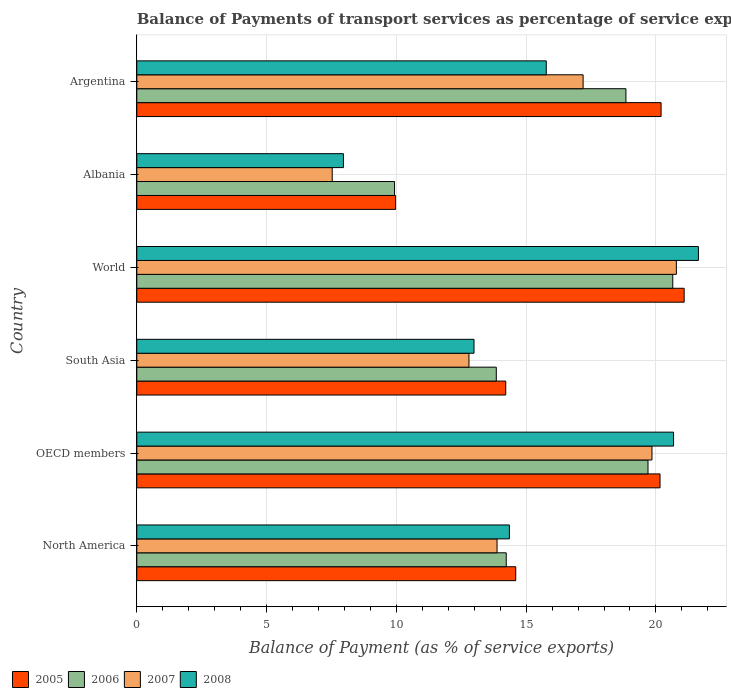How many different coloured bars are there?
Make the answer very short. 4. How many groups of bars are there?
Your response must be concise. 6. How many bars are there on the 1st tick from the top?
Your answer should be very brief. 4. How many bars are there on the 1st tick from the bottom?
Make the answer very short. 4. What is the label of the 1st group of bars from the top?
Keep it short and to the point. Argentina. In how many cases, is the number of bars for a given country not equal to the number of legend labels?
Your answer should be very brief. 0. What is the balance of payments of transport services in 2005 in South Asia?
Make the answer very short. 14.21. Across all countries, what is the maximum balance of payments of transport services in 2008?
Keep it short and to the point. 21.64. Across all countries, what is the minimum balance of payments of transport services in 2005?
Your response must be concise. 9.97. In which country was the balance of payments of transport services in 2007 maximum?
Give a very brief answer. World. In which country was the balance of payments of transport services in 2005 minimum?
Give a very brief answer. Albania. What is the total balance of payments of transport services in 2007 in the graph?
Your answer should be compact. 92.03. What is the difference between the balance of payments of transport services in 2006 in North America and that in OECD members?
Offer a terse response. -5.46. What is the difference between the balance of payments of transport services in 2008 in South Asia and the balance of payments of transport services in 2005 in OECD members?
Your response must be concise. -7.17. What is the average balance of payments of transport services in 2008 per country?
Make the answer very short. 15.57. What is the difference between the balance of payments of transport services in 2006 and balance of payments of transport services in 2005 in North America?
Offer a terse response. -0.37. In how many countries, is the balance of payments of transport services in 2008 greater than 3 %?
Provide a short and direct response. 6. What is the ratio of the balance of payments of transport services in 2008 in Argentina to that in North America?
Ensure brevity in your answer.  1.1. Is the difference between the balance of payments of transport services in 2006 in Albania and Argentina greater than the difference between the balance of payments of transport services in 2005 in Albania and Argentina?
Make the answer very short. Yes. What is the difference between the highest and the second highest balance of payments of transport services in 2007?
Make the answer very short. 0.94. What is the difference between the highest and the lowest balance of payments of transport services in 2008?
Offer a terse response. 13.68. In how many countries, is the balance of payments of transport services in 2007 greater than the average balance of payments of transport services in 2007 taken over all countries?
Keep it short and to the point. 3. Is it the case that in every country, the sum of the balance of payments of transport services in 2008 and balance of payments of transport services in 2005 is greater than the balance of payments of transport services in 2006?
Keep it short and to the point. Yes. Are all the bars in the graph horizontal?
Keep it short and to the point. Yes. How many countries are there in the graph?
Keep it short and to the point. 6. Does the graph contain any zero values?
Make the answer very short. No. Does the graph contain grids?
Your answer should be very brief. Yes. How are the legend labels stacked?
Your answer should be compact. Horizontal. What is the title of the graph?
Offer a very short reply. Balance of Payments of transport services as percentage of service exports. What is the label or title of the X-axis?
Offer a terse response. Balance of Payment (as % of service exports). What is the Balance of Payment (as % of service exports) of 2005 in North America?
Your response must be concise. 14.6. What is the Balance of Payment (as % of service exports) of 2006 in North America?
Your response must be concise. 14.23. What is the Balance of Payment (as % of service exports) in 2007 in North America?
Provide a succinct answer. 13.88. What is the Balance of Payment (as % of service exports) in 2008 in North America?
Your answer should be very brief. 14.35. What is the Balance of Payment (as % of service exports) in 2005 in OECD members?
Offer a terse response. 20.16. What is the Balance of Payment (as % of service exports) in 2006 in OECD members?
Offer a terse response. 19.69. What is the Balance of Payment (as % of service exports) in 2007 in OECD members?
Your response must be concise. 19.85. What is the Balance of Payment (as % of service exports) of 2008 in OECD members?
Your answer should be very brief. 20.68. What is the Balance of Payment (as % of service exports) of 2005 in South Asia?
Offer a very short reply. 14.21. What is the Balance of Payment (as % of service exports) of 2006 in South Asia?
Your response must be concise. 13.85. What is the Balance of Payment (as % of service exports) in 2007 in South Asia?
Give a very brief answer. 12.8. What is the Balance of Payment (as % of service exports) in 2008 in South Asia?
Offer a very short reply. 12.99. What is the Balance of Payment (as % of service exports) of 2005 in World?
Provide a short and direct response. 21.09. What is the Balance of Payment (as % of service exports) of 2006 in World?
Your response must be concise. 20.65. What is the Balance of Payment (as % of service exports) of 2007 in World?
Give a very brief answer. 20.79. What is the Balance of Payment (as % of service exports) in 2008 in World?
Keep it short and to the point. 21.64. What is the Balance of Payment (as % of service exports) of 2005 in Albania?
Offer a terse response. 9.97. What is the Balance of Payment (as % of service exports) of 2006 in Albania?
Provide a short and direct response. 9.93. What is the Balance of Payment (as % of service exports) in 2007 in Albania?
Offer a very short reply. 7.53. What is the Balance of Payment (as % of service exports) of 2008 in Albania?
Your answer should be compact. 7.96. What is the Balance of Payment (as % of service exports) in 2005 in Argentina?
Your answer should be compact. 20.2. What is the Balance of Payment (as % of service exports) in 2006 in Argentina?
Offer a terse response. 18.84. What is the Balance of Payment (as % of service exports) of 2007 in Argentina?
Your response must be concise. 17.19. What is the Balance of Payment (as % of service exports) in 2008 in Argentina?
Your response must be concise. 15.78. Across all countries, what is the maximum Balance of Payment (as % of service exports) of 2005?
Your answer should be compact. 21.09. Across all countries, what is the maximum Balance of Payment (as % of service exports) of 2006?
Your answer should be compact. 20.65. Across all countries, what is the maximum Balance of Payment (as % of service exports) of 2007?
Provide a short and direct response. 20.79. Across all countries, what is the maximum Balance of Payment (as % of service exports) of 2008?
Your answer should be compact. 21.64. Across all countries, what is the minimum Balance of Payment (as % of service exports) of 2005?
Your answer should be very brief. 9.97. Across all countries, what is the minimum Balance of Payment (as % of service exports) in 2006?
Ensure brevity in your answer.  9.93. Across all countries, what is the minimum Balance of Payment (as % of service exports) of 2007?
Offer a very short reply. 7.53. Across all countries, what is the minimum Balance of Payment (as % of service exports) of 2008?
Provide a short and direct response. 7.96. What is the total Balance of Payment (as % of service exports) of 2005 in the graph?
Make the answer very short. 100.23. What is the total Balance of Payment (as % of service exports) in 2006 in the graph?
Your answer should be compact. 97.2. What is the total Balance of Payment (as % of service exports) in 2007 in the graph?
Provide a succinct answer. 92.03. What is the total Balance of Payment (as % of service exports) in 2008 in the graph?
Offer a very short reply. 93.4. What is the difference between the Balance of Payment (as % of service exports) in 2005 in North America and that in OECD members?
Give a very brief answer. -5.56. What is the difference between the Balance of Payment (as % of service exports) of 2006 in North America and that in OECD members?
Ensure brevity in your answer.  -5.46. What is the difference between the Balance of Payment (as % of service exports) in 2007 in North America and that in OECD members?
Your response must be concise. -5.97. What is the difference between the Balance of Payment (as % of service exports) of 2008 in North America and that in OECD members?
Ensure brevity in your answer.  -6.32. What is the difference between the Balance of Payment (as % of service exports) of 2005 in North America and that in South Asia?
Offer a terse response. 0.38. What is the difference between the Balance of Payment (as % of service exports) of 2006 in North America and that in South Asia?
Give a very brief answer. 0.38. What is the difference between the Balance of Payment (as % of service exports) of 2007 in North America and that in South Asia?
Give a very brief answer. 1.08. What is the difference between the Balance of Payment (as % of service exports) in 2008 in North America and that in South Asia?
Provide a succinct answer. 1.36. What is the difference between the Balance of Payment (as % of service exports) in 2005 in North America and that in World?
Ensure brevity in your answer.  -6.49. What is the difference between the Balance of Payment (as % of service exports) of 2006 in North America and that in World?
Offer a terse response. -6.42. What is the difference between the Balance of Payment (as % of service exports) of 2007 in North America and that in World?
Offer a terse response. -6.91. What is the difference between the Balance of Payment (as % of service exports) of 2008 in North America and that in World?
Your answer should be compact. -7.28. What is the difference between the Balance of Payment (as % of service exports) of 2005 in North America and that in Albania?
Offer a very short reply. 4.63. What is the difference between the Balance of Payment (as % of service exports) of 2006 in North America and that in Albania?
Keep it short and to the point. 4.3. What is the difference between the Balance of Payment (as % of service exports) in 2007 in North America and that in Albania?
Ensure brevity in your answer.  6.35. What is the difference between the Balance of Payment (as % of service exports) in 2008 in North America and that in Albania?
Keep it short and to the point. 6.39. What is the difference between the Balance of Payment (as % of service exports) of 2005 in North America and that in Argentina?
Provide a succinct answer. -5.6. What is the difference between the Balance of Payment (as % of service exports) in 2006 in North America and that in Argentina?
Your answer should be compact. -4.61. What is the difference between the Balance of Payment (as % of service exports) in 2007 in North America and that in Argentina?
Offer a very short reply. -3.32. What is the difference between the Balance of Payment (as % of service exports) in 2008 in North America and that in Argentina?
Make the answer very short. -1.42. What is the difference between the Balance of Payment (as % of service exports) in 2005 in OECD members and that in South Asia?
Provide a short and direct response. 5.94. What is the difference between the Balance of Payment (as % of service exports) in 2006 in OECD members and that in South Asia?
Your answer should be very brief. 5.84. What is the difference between the Balance of Payment (as % of service exports) in 2007 in OECD members and that in South Asia?
Give a very brief answer. 7.05. What is the difference between the Balance of Payment (as % of service exports) of 2008 in OECD members and that in South Asia?
Give a very brief answer. 7.69. What is the difference between the Balance of Payment (as % of service exports) of 2005 in OECD members and that in World?
Ensure brevity in your answer.  -0.93. What is the difference between the Balance of Payment (as % of service exports) in 2006 in OECD members and that in World?
Your answer should be very brief. -0.95. What is the difference between the Balance of Payment (as % of service exports) in 2007 in OECD members and that in World?
Provide a short and direct response. -0.94. What is the difference between the Balance of Payment (as % of service exports) of 2008 in OECD members and that in World?
Keep it short and to the point. -0.96. What is the difference between the Balance of Payment (as % of service exports) in 2005 in OECD members and that in Albania?
Keep it short and to the point. 10.19. What is the difference between the Balance of Payment (as % of service exports) in 2006 in OECD members and that in Albania?
Give a very brief answer. 9.76. What is the difference between the Balance of Payment (as % of service exports) of 2007 in OECD members and that in Albania?
Offer a terse response. 12.32. What is the difference between the Balance of Payment (as % of service exports) of 2008 in OECD members and that in Albania?
Your response must be concise. 12.72. What is the difference between the Balance of Payment (as % of service exports) in 2005 in OECD members and that in Argentina?
Provide a succinct answer. -0.04. What is the difference between the Balance of Payment (as % of service exports) of 2006 in OECD members and that in Argentina?
Make the answer very short. 0.85. What is the difference between the Balance of Payment (as % of service exports) in 2007 in OECD members and that in Argentina?
Make the answer very short. 2.65. What is the difference between the Balance of Payment (as % of service exports) of 2008 in OECD members and that in Argentina?
Provide a short and direct response. 4.9. What is the difference between the Balance of Payment (as % of service exports) in 2005 in South Asia and that in World?
Provide a short and direct response. -6.87. What is the difference between the Balance of Payment (as % of service exports) in 2006 in South Asia and that in World?
Offer a very short reply. -6.8. What is the difference between the Balance of Payment (as % of service exports) in 2007 in South Asia and that in World?
Your answer should be compact. -7.99. What is the difference between the Balance of Payment (as % of service exports) in 2008 in South Asia and that in World?
Offer a very short reply. -8.64. What is the difference between the Balance of Payment (as % of service exports) of 2005 in South Asia and that in Albania?
Your response must be concise. 4.24. What is the difference between the Balance of Payment (as % of service exports) of 2006 in South Asia and that in Albania?
Your answer should be compact. 3.92. What is the difference between the Balance of Payment (as % of service exports) of 2007 in South Asia and that in Albania?
Your response must be concise. 5.27. What is the difference between the Balance of Payment (as % of service exports) of 2008 in South Asia and that in Albania?
Ensure brevity in your answer.  5.03. What is the difference between the Balance of Payment (as % of service exports) of 2005 in South Asia and that in Argentina?
Provide a succinct answer. -5.98. What is the difference between the Balance of Payment (as % of service exports) of 2006 in South Asia and that in Argentina?
Give a very brief answer. -4.99. What is the difference between the Balance of Payment (as % of service exports) of 2007 in South Asia and that in Argentina?
Provide a short and direct response. -4.4. What is the difference between the Balance of Payment (as % of service exports) of 2008 in South Asia and that in Argentina?
Provide a succinct answer. -2.78. What is the difference between the Balance of Payment (as % of service exports) in 2005 in World and that in Albania?
Provide a succinct answer. 11.12. What is the difference between the Balance of Payment (as % of service exports) in 2006 in World and that in Albania?
Keep it short and to the point. 10.72. What is the difference between the Balance of Payment (as % of service exports) of 2007 in World and that in Albania?
Offer a very short reply. 13.26. What is the difference between the Balance of Payment (as % of service exports) of 2008 in World and that in Albania?
Provide a short and direct response. 13.68. What is the difference between the Balance of Payment (as % of service exports) of 2005 in World and that in Argentina?
Your response must be concise. 0.89. What is the difference between the Balance of Payment (as % of service exports) of 2006 in World and that in Argentina?
Your answer should be compact. 1.8. What is the difference between the Balance of Payment (as % of service exports) of 2007 in World and that in Argentina?
Your answer should be compact. 3.59. What is the difference between the Balance of Payment (as % of service exports) in 2008 in World and that in Argentina?
Your answer should be compact. 5.86. What is the difference between the Balance of Payment (as % of service exports) of 2005 in Albania and that in Argentina?
Offer a terse response. -10.23. What is the difference between the Balance of Payment (as % of service exports) in 2006 in Albania and that in Argentina?
Your answer should be compact. -8.91. What is the difference between the Balance of Payment (as % of service exports) of 2007 in Albania and that in Argentina?
Make the answer very short. -9.67. What is the difference between the Balance of Payment (as % of service exports) in 2008 in Albania and that in Argentina?
Offer a very short reply. -7.81. What is the difference between the Balance of Payment (as % of service exports) in 2005 in North America and the Balance of Payment (as % of service exports) in 2006 in OECD members?
Ensure brevity in your answer.  -5.1. What is the difference between the Balance of Payment (as % of service exports) of 2005 in North America and the Balance of Payment (as % of service exports) of 2007 in OECD members?
Offer a terse response. -5.25. What is the difference between the Balance of Payment (as % of service exports) in 2005 in North America and the Balance of Payment (as % of service exports) in 2008 in OECD members?
Keep it short and to the point. -6.08. What is the difference between the Balance of Payment (as % of service exports) of 2006 in North America and the Balance of Payment (as % of service exports) of 2007 in OECD members?
Give a very brief answer. -5.61. What is the difference between the Balance of Payment (as % of service exports) in 2006 in North America and the Balance of Payment (as % of service exports) in 2008 in OECD members?
Give a very brief answer. -6.45. What is the difference between the Balance of Payment (as % of service exports) of 2007 in North America and the Balance of Payment (as % of service exports) of 2008 in OECD members?
Make the answer very short. -6.8. What is the difference between the Balance of Payment (as % of service exports) in 2005 in North America and the Balance of Payment (as % of service exports) in 2006 in South Asia?
Give a very brief answer. 0.75. What is the difference between the Balance of Payment (as % of service exports) in 2005 in North America and the Balance of Payment (as % of service exports) in 2007 in South Asia?
Keep it short and to the point. 1.8. What is the difference between the Balance of Payment (as % of service exports) in 2005 in North America and the Balance of Payment (as % of service exports) in 2008 in South Asia?
Your response must be concise. 1.61. What is the difference between the Balance of Payment (as % of service exports) in 2006 in North America and the Balance of Payment (as % of service exports) in 2007 in South Asia?
Offer a terse response. 1.44. What is the difference between the Balance of Payment (as % of service exports) of 2006 in North America and the Balance of Payment (as % of service exports) of 2008 in South Asia?
Provide a short and direct response. 1.24. What is the difference between the Balance of Payment (as % of service exports) of 2007 in North America and the Balance of Payment (as % of service exports) of 2008 in South Asia?
Ensure brevity in your answer.  0.89. What is the difference between the Balance of Payment (as % of service exports) in 2005 in North America and the Balance of Payment (as % of service exports) in 2006 in World?
Give a very brief answer. -6.05. What is the difference between the Balance of Payment (as % of service exports) of 2005 in North America and the Balance of Payment (as % of service exports) of 2007 in World?
Your answer should be very brief. -6.19. What is the difference between the Balance of Payment (as % of service exports) in 2005 in North America and the Balance of Payment (as % of service exports) in 2008 in World?
Make the answer very short. -7.04. What is the difference between the Balance of Payment (as % of service exports) of 2006 in North America and the Balance of Payment (as % of service exports) of 2007 in World?
Offer a terse response. -6.55. What is the difference between the Balance of Payment (as % of service exports) in 2006 in North America and the Balance of Payment (as % of service exports) in 2008 in World?
Provide a short and direct response. -7.4. What is the difference between the Balance of Payment (as % of service exports) of 2007 in North America and the Balance of Payment (as % of service exports) of 2008 in World?
Offer a very short reply. -7.76. What is the difference between the Balance of Payment (as % of service exports) of 2005 in North America and the Balance of Payment (as % of service exports) of 2006 in Albania?
Make the answer very short. 4.67. What is the difference between the Balance of Payment (as % of service exports) of 2005 in North America and the Balance of Payment (as % of service exports) of 2007 in Albania?
Provide a short and direct response. 7.07. What is the difference between the Balance of Payment (as % of service exports) of 2005 in North America and the Balance of Payment (as % of service exports) of 2008 in Albania?
Keep it short and to the point. 6.64. What is the difference between the Balance of Payment (as % of service exports) in 2006 in North America and the Balance of Payment (as % of service exports) in 2007 in Albania?
Ensure brevity in your answer.  6.7. What is the difference between the Balance of Payment (as % of service exports) of 2006 in North America and the Balance of Payment (as % of service exports) of 2008 in Albania?
Your answer should be very brief. 6.27. What is the difference between the Balance of Payment (as % of service exports) of 2007 in North America and the Balance of Payment (as % of service exports) of 2008 in Albania?
Your answer should be very brief. 5.92. What is the difference between the Balance of Payment (as % of service exports) of 2005 in North America and the Balance of Payment (as % of service exports) of 2006 in Argentina?
Offer a terse response. -4.24. What is the difference between the Balance of Payment (as % of service exports) in 2005 in North America and the Balance of Payment (as % of service exports) in 2007 in Argentina?
Keep it short and to the point. -2.6. What is the difference between the Balance of Payment (as % of service exports) of 2005 in North America and the Balance of Payment (as % of service exports) of 2008 in Argentina?
Offer a very short reply. -1.18. What is the difference between the Balance of Payment (as % of service exports) in 2006 in North America and the Balance of Payment (as % of service exports) in 2007 in Argentina?
Your response must be concise. -2.96. What is the difference between the Balance of Payment (as % of service exports) in 2006 in North America and the Balance of Payment (as % of service exports) in 2008 in Argentina?
Your answer should be very brief. -1.54. What is the difference between the Balance of Payment (as % of service exports) of 2007 in North America and the Balance of Payment (as % of service exports) of 2008 in Argentina?
Make the answer very short. -1.9. What is the difference between the Balance of Payment (as % of service exports) of 2005 in OECD members and the Balance of Payment (as % of service exports) of 2006 in South Asia?
Your response must be concise. 6.31. What is the difference between the Balance of Payment (as % of service exports) in 2005 in OECD members and the Balance of Payment (as % of service exports) in 2007 in South Asia?
Provide a succinct answer. 7.36. What is the difference between the Balance of Payment (as % of service exports) in 2005 in OECD members and the Balance of Payment (as % of service exports) in 2008 in South Asia?
Provide a succinct answer. 7.17. What is the difference between the Balance of Payment (as % of service exports) of 2006 in OECD members and the Balance of Payment (as % of service exports) of 2007 in South Asia?
Give a very brief answer. 6.9. What is the difference between the Balance of Payment (as % of service exports) of 2006 in OECD members and the Balance of Payment (as % of service exports) of 2008 in South Asia?
Give a very brief answer. 6.7. What is the difference between the Balance of Payment (as % of service exports) of 2007 in OECD members and the Balance of Payment (as % of service exports) of 2008 in South Asia?
Offer a terse response. 6.86. What is the difference between the Balance of Payment (as % of service exports) in 2005 in OECD members and the Balance of Payment (as % of service exports) in 2006 in World?
Ensure brevity in your answer.  -0.49. What is the difference between the Balance of Payment (as % of service exports) in 2005 in OECD members and the Balance of Payment (as % of service exports) in 2007 in World?
Provide a succinct answer. -0.63. What is the difference between the Balance of Payment (as % of service exports) of 2005 in OECD members and the Balance of Payment (as % of service exports) of 2008 in World?
Give a very brief answer. -1.48. What is the difference between the Balance of Payment (as % of service exports) of 2006 in OECD members and the Balance of Payment (as % of service exports) of 2007 in World?
Offer a very short reply. -1.09. What is the difference between the Balance of Payment (as % of service exports) of 2006 in OECD members and the Balance of Payment (as % of service exports) of 2008 in World?
Keep it short and to the point. -1.94. What is the difference between the Balance of Payment (as % of service exports) of 2007 in OECD members and the Balance of Payment (as % of service exports) of 2008 in World?
Give a very brief answer. -1.79. What is the difference between the Balance of Payment (as % of service exports) in 2005 in OECD members and the Balance of Payment (as % of service exports) in 2006 in Albania?
Ensure brevity in your answer.  10.23. What is the difference between the Balance of Payment (as % of service exports) of 2005 in OECD members and the Balance of Payment (as % of service exports) of 2007 in Albania?
Your answer should be compact. 12.63. What is the difference between the Balance of Payment (as % of service exports) in 2005 in OECD members and the Balance of Payment (as % of service exports) in 2008 in Albania?
Your answer should be very brief. 12.2. What is the difference between the Balance of Payment (as % of service exports) of 2006 in OECD members and the Balance of Payment (as % of service exports) of 2007 in Albania?
Keep it short and to the point. 12.17. What is the difference between the Balance of Payment (as % of service exports) in 2006 in OECD members and the Balance of Payment (as % of service exports) in 2008 in Albania?
Offer a very short reply. 11.73. What is the difference between the Balance of Payment (as % of service exports) of 2007 in OECD members and the Balance of Payment (as % of service exports) of 2008 in Albania?
Offer a terse response. 11.89. What is the difference between the Balance of Payment (as % of service exports) in 2005 in OECD members and the Balance of Payment (as % of service exports) in 2006 in Argentina?
Provide a succinct answer. 1.31. What is the difference between the Balance of Payment (as % of service exports) of 2005 in OECD members and the Balance of Payment (as % of service exports) of 2007 in Argentina?
Keep it short and to the point. 2.96. What is the difference between the Balance of Payment (as % of service exports) of 2005 in OECD members and the Balance of Payment (as % of service exports) of 2008 in Argentina?
Ensure brevity in your answer.  4.38. What is the difference between the Balance of Payment (as % of service exports) in 2006 in OECD members and the Balance of Payment (as % of service exports) in 2007 in Argentina?
Keep it short and to the point. 2.5. What is the difference between the Balance of Payment (as % of service exports) in 2006 in OECD members and the Balance of Payment (as % of service exports) in 2008 in Argentina?
Your response must be concise. 3.92. What is the difference between the Balance of Payment (as % of service exports) of 2007 in OECD members and the Balance of Payment (as % of service exports) of 2008 in Argentina?
Provide a succinct answer. 4.07. What is the difference between the Balance of Payment (as % of service exports) in 2005 in South Asia and the Balance of Payment (as % of service exports) in 2006 in World?
Your answer should be compact. -6.43. What is the difference between the Balance of Payment (as % of service exports) in 2005 in South Asia and the Balance of Payment (as % of service exports) in 2007 in World?
Make the answer very short. -6.57. What is the difference between the Balance of Payment (as % of service exports) in 2005 in South Asia and the Balance of Payment (as % of service exports) in 2008 in World?
Keep it short and to the point. -7.42. What is the difference between the Balance of Payment (as % of service exports) of 2006 in South Asia and the Balance of Payment (as % of service exports) of 2007 in World?
Make the answer very short. -6.94. What is the difference between the Balance of Payment (as % of service exports) of 2006 in South Asia and the Balance of Payment (as % of service exports) of 2008 in World?
Your response must be concise. -7.79. What is the difference between the Balance of Payment (as % of service exports) of 2007 in South Asia and the Balance of Payment (as % of service exports) of 2008 in World?
Ensure brevity in your answer.  -8.84. What is the difference between the Balance of Payment (as % of service exports) of 2005 in South Asia and the Balance of Payment (as % of service exports) of 2006 in Albania?
Your response must be concise. 4.28. What is the difference between the Balance of Payment (as % of service exports) in 2005 in South Asia and the Balance of Payment (as % of service exports) in 2007 in Albania?
Make the answer very short. 6.68. What is the difference between the Balance of Payment (as % of service exports) of 2005 in South Asia and the Balance of Payment (as % of service exports) of 2008 in Albania?
Make the answer very short. 6.25. What is the difference between the Balance of Payment (as % of service exports) in 2006 in South Asia and the Balance of Payment (as % of service exports) in 2007 in Albania?
Your answer should be compact. 6.32. What is the difference between the Balance of Payment (as % of service exports) in 2006 in South Asia and the Balance of Payment (as % of service exports) in 2008 in Albania?
Your answer should be very brief. 5.89. What is the difference between the Balance of Payment (as % of service exports) in 2007 in South Asia and the Balance of Payment (as % of service exports) in 2008 in Albania?
Keep it short and to the point. 4.84. What is the difference between the Balance of Payment (as % of service exports) of 2005 in South Asia and the Balance of Payment (as % of service exports) of 2006 in Argentina?
Offer a terse response. -4.63. What is the difference between the Balance of Payment (as % of service exports) of 2005 in South Asia and the Balance of Payment (as % of service exports) of 2007 in Argentina?
Offer a terse response. -2.98. What is the difference between the Balance of Payment (as % of service exports) of 2005 in South Asia and the Balance of Payment (as % of service exports) of 2008 in Argentina?
Provide a succinct answer. -1.56. What is the difference between the Balance of Payment (as % of service exports) of 2006 in South Asia and the Balance of Payment (as % of service exports) of 2007 in Argentina?
Ensure brevity in your answer.  -3.34. What is the difference between the Balance of Payment (as % of service exports) in 2006 in South Asia and the Balance of Payment (as % of service exports) in 2008 in Argentina?
Give a very brief answer. -1.93. What is the difference between the Balance of Payment (as % of service exports) of 2007 in South Asia and the Balance of Payment (as % of service exports) of 2008 in Argentina?
Your response must be concise. -2.98. What is the difference between the Balance of Payment (as % of service exports) of 2005 in World and the Balance of Payment (as % of service exports) of 2006 in Albania?
Provide a succinct answer. 11.16. What is the difference between the Balance of Payment (as % of service exports) of 2005 in World and the Balance of Payment (as % of service exports) of 2007 in Albania?
Give a very brief answer. 13.56. What is the difference between the Balance of Payment (as % of service exports) of 2005 in World and the Balance of Payment (as % of service exports) of 2008 in Albania?
Your answer should be compact. 13.13. What is the difference between the Balance of Payment (as % of service exports) in 2006 in World and the Balance of Payment (as % of service exports) in 2007 in Albania?
Make the answer very short. 13.12. What is the difference between the Balance of Payment (as % of service exports) of 2006 in World and the Balance of Payment (as % of service exports) of 2008 in Albania?
Your response must be concise. 12.69. What is the difference between the Balance of Payment (as % of service exports) in 2007 in World and the Balance of Payment (as % of service exports) in 2008 in Albania?
Make the answer very short. 12.83. What is the difference between the Balance of Payment (as % of service exports) of 2005 in World and the Balance of Payment (as % of service exports) of 2006 in Argentina?
Keep it short and to the point. 2.24. What is the difference between the Balance of Payment (as % of service exports) in 2005 in World and the Balance of Payment (as % of service exports) in 2007 in Argentina?
Offer a very short reply. 3.89. What is the difference between the Balance of Payment (as % of service exports) in 2005 in World and the Balance of Payment (as % of service exports) in 2008 in Argentina?
Your response must be concise. 5.31. What is the difference between the Balance of Payment (as % of service exports) of 2006 in World and the Balance of Payment (as % of service exports) of 2007 in Argentina?
Offer a very short reply. 3.45. What is the difference between the Balance of Payment (as % of service exports) of 2006 in World and the Balance of Payment (as % of service exports) of 2008 in Argentina?
Ensure brevity in your answer.  4.87. What is the difference between the Balance of Payment (as % of service exports) of 2007 in World and the Balance of Payment (as % of service exports) of 2008 in Argentina?
Give a very brief answer. 5.01. What is the difference between the Balance of Payment (as % of service exports) in 2005 in Albania and the Balance of Payment (as % of service exports) in 2006 in Argentina?
Keep it short and to the point. -8.87. What is the difference between the Balance of Payment (as % of service exports) in 2005 in Albania and the Balance of Payment (as % of service exports) in 2007 in Argentina?
Your answer should be very brief. -7.22. What is the difference between the Balance of Payment (as % of service exports) in 2005 in Albania and the Balance of Payment (as % of service exports) in 2008 in Argentina?
Your response must be concise. -5.8. What is the difference between the Balance of Payment (as % of service exports) in 2006 in Albania and the Balance of Payment (as % of service exports) in 2007 in Argentina?
Keep it short and to the point. -7.26. What is the difference between the Balance of Payment (as % of service exports) of 2006 in Albania and the Balance of Payment (as % of service exports) of 2008 in Argentina?
Offer a very short reply. -5.85. What is the difference between the Balance of Payment (as % of service exports) in 2007 in Albania and the Balance of Payment (as % of service exports) in 2008 in Argentina?
Provide a succinct answer. -8.25. What is the average Balance of Payment (as % of service exports) in 2005 per country?
Offer a very short reply. 16.7. What is the average Balance of Payment (as % of service exports) in 2006 per country?
Offer a very short reply. 16.2. What is the average Balance of Payment (as % of service exports) in 2007 per country?
Provide a succinct answer. 15.34. What is the average Balance of Payment (as % of service exports) in 2008 per country?
Provide a succinct answer. 15.57. What is the difference between the Balance of Payment (as % of service exports) in 2005 and Balance of Payment (as % of service exports) in 2006 in North America?
Make the answer very short. 0.37. What is the difference between the Balance of Payment (as % of service exports) in 2005 and Balance of Payment (as % of service exports) in 2007 in North America?
Provide a succinct answer. 0.72. What is the difference between the Balance of Payment (as % of service exports) in 2005 and Balance of Payment (as % of service exports) in 2008 in North America?
Offer a terse response. 0.24. What is the difference between the Balance of Payment (as % of service exports) of 2006 and Balance of Payment (as % of service exports) of 2007 in North America?
Offer a terse response. 0.35. What is the difference between the Balance of Payment (as % of service exports) of 2006 and Balance of Payment (as % of service exports) of 2008 in North America?
Keep it short and to the point. -0.12. What is the difference between the Balance of Payment (as % of service exports) in 2007 and Balance of Payment (as % of service exports) in 2008 in North America?
Make the answer very short. -0.48. What is the difference between the Balance of Payment (as % of service exports) of 2005 and Balance of Payment (as % of service exports) of 2006 in OECD members?
Your response must be concise. 0.46. What is the difference between the Balance of Payment (as % of service exports) in 2005 and Balance of Payment (as % of service exports) in 2007 in OECD members?
Your answer should be compact. 0.31. What is the difference between the Balance of Payment (as % of service exports) in 2005 and Balance of Payment (as % of service exports) in 2008 in OECD members?
Make the answer very short. -0.52. What is the difference between the Balance of Payment (as % of service exports) of 2006 and Balance of Payment (as % of service exports) of 2007 in OECD members?
Make the answer very short. -0.15. What is the difference between the Balance of Payment (as % of service exports) of 2006 and Balance of Payment (as % of service exports) of 2008 in OECD members?
Provide a succinct answer. -0.98. What is the difference between the Balance of Payment (as % of service exports) in 2007 and Balance of Payment (as % of service exports) in 2008 in OECD members?
Your answer should be compact. -0.83. What is the difference between the Balance of Payment (as % of service exports) in 2005 and Balance of Payment (as % of service exports) in 2006 in South Asia?
Your answer should be compact. 0.36. What is the difference between the Balance of Payment (as % of service exports) in 2005 and Balance of Payment (as % of service exports) in 2007 in South Asia?
Ensure brevity in your answer.  1.42. What is the difference between the Balance of Payment (as % of service exports) in 2005 and Balance of Payment (as % of service exports) in 2008 in South Asia?
Offer a terse response. 1.22. What is the difference between the Balance of Payment (as % of service exports) in 2006 and Balance of Payment (as % of service exports) in 2007 in South Asia?
Provide a succinct answer. 1.05. What is the difference between the Balance of Payment (as % of service exports) of 2006 and Balance of Payment (as % of service exports) of 2008 in South Asia?
Your response must be concise. 0.86. What is the difference between the Balance of Payment (as % of service exports) of 2007 and Balance of Payment (as % of service exports) of 2008 in South Asia?
Give a very brief answer. -0.19. What is the difference between the Balance of Payment (as % of service exports) of 2005 and Balance of Payment (as % of service exports) of 2006 in World?
Provide a succinct answer. 0.44. What is the difference between the Balance of Payment (as % of service exports) of 2005 and Balance of Payment (as % of service exports) of 2007 in World?
Offer a very short reply. 0.3. What is the difference between the Balance of Payment (as % of service exports) of 2005 and Balance of Payment (as % of service exports) of 2008 in World?
Offer a very short reply. -0.55. What is the difference between the Balance of Payment (as % of service exports) of 2006 and Balance of Payment (as % of service exports) of 2007 in World?
Ensure brevity in your answer.  -0.14. What is the difference between the Balance of Payment (as % of service exports) in 2006 and Balance of Payment (as % of service exports) in 2008 in World?
Ensure brevity in your answer.  -0.99. What is the difference between the Balance of Payment (as % of service exports) in 2007 and Balance of Payment (as % of service exports) in 2008 in World?
Keep it short and to the point. -0.85. What is the difference between the Balance of Payment (as % of service exports) in 2005 and Balance of Payment (as % of service exports) in 2006 in Albania?
Ensure brevity in your answer.  0.04. What is the difference between the Balance of Payment (as % of service exports) of 2005 and Balance of Payment (as % of service exports) of 2007 in Albania?
Give a very brief answer. 2.44. What is the difference between the Balance of Payment (as % of service exports) of 2005 and Balance of Payment (as % of service exports) of 2008 in Albania?
Your response must be concise. 2.01. What is the difference between the Balance of Payment (as % of service exports) of 2006 and Balance of Payment (as % of service exports) of 2007 in Albania?
Provide a succinct answer. 2.4. What is the difference between the Balance of Payment (as % of service exports) of 2006 and Balance of Payment (as % of service exports) of 2008 in Albania?
Provide a short and direct response. 1.97. What is the difference between the Balance of Payment (as % of service exports) of 2007 and Balance of Payment (as % of service exports) of 2008 in Albania?
Provide a short and direct response. -0.43. What is the difference between the Balance of Payment (as % of service exports) of 2005 and Balance of Payment (as % of service exports) of 2006 in Argentina?
Your response must be concise. 1.35. What is the difference between the Balance of Payment (as % of service exports) in 2005 and Balance of Payment (as % of service exports) in 2007 in Argentina?
Your answer should be very brief. 3. What is the difference between the Balance of Payment (as % of service exports) of 2005 and Balance of Payment (as % of service exports) of 2008 in Argentina?
Provide a succinct answer. 4.42. What is the difference between the Balance of Payment (as % of service exports) of 2006 and Balance of Payment (as % of service exports) of 2007 in Argentina?
Ensure brevity in your answer.  1.65. What is the difference between the Balance of Payment (as % of service exports) in 2006 and Balance of Payment (as % of service exports) in 2008 in Argentina?
Your answer should be compact. 3.07. What is the difference between the Balance of Payment (as % of service exports) in 2007 and Balance of Payment (as % of service exports) in 2008 in Argentina?
Keep it short and to the point. 1.42. What is the ratio of the Balance of Payment (as % of service exports) in 2005 in North America to that in OECD members?
Your answer should be very brief. 0.72. What is the ratio of the Balance of Payment (as % of service exports) of 2006 in North America to that in OECD members?
Give a very brief answer. 0.72. What is the ratio of the Balance of Payment (as % of service exports) in 2007 in North America to that in OECD members?
Ensure brevity in your answer.  0.7. What is the ratio of the Balance of Payment (as % of service exports) of 2008 in North America to that in OECD members?
Give a very brief answer. 0.69. What is the ratio of the Balance of Payment (as % of service exports) of 2005 in North America to that in South Asia?
Your answer should be very brief. 1.03. What is the ratio of the Balance of Payment (as % of service exports) in 2006 in North America to that in South Asia?
Keep it short and to the point. 1.03. What is the ratio of the Balance of Payment (as % of service exports) of 2007 in North America to that in South Asia?
Ensure brevity in your answer.  1.08. What is the ratio of the Balance of Payment (as % of service exports) of 2008 in North America to that in South Asia?
Keep it short and to the point. 1.1. What is the ratio of the Balance of Payment (as % of service exports) in 2005 in North America to that in World?
Give a very brief answer. 0.69. What is the ratio of the Balance of Payment (as % of service exports) in 2006 in North America to that in World?
Offer a very short reply. 0.69. What is the ratio of the Balance of Payment (as % of service exports) in 2007 in North America to that in World?
Give a very brief answer. 0.67. What is the ratio of the Balance of Payment (as % of service exports) in 2008 in North America to that in World?
Offer a very short reply. 0.66. What is the ratio of the Balance of Payment (as % of service exports) in 2005 in North America to that in Albania?
Your response must be concise. 1.46. What is the ratio of the Balance of Payment (as % of service exports) of 2006 in North America to that in Albania?
Provide a succinct answer. 1.43. What is the ratio of the Balance of Payment (as % of service exports) in 2007 in North America to that in Albania?
Give a very brief answer. 1.84. What is the ratio of the Balance of Payment (as % of service exports) in 2008 in North America to that in Albania?
Provide a short and direct response. 1.8. What is the ratio of the Balance of Payment (as % of service exports) of 2005 in North America to that in Argentina?
Your answer should be compact. 0.72. What is the ratio of the Balance of Payment (as % of service exports) of 2006 in North America to that in Argentina?
Give a very brief answer. 0.76. What is the ratio of the Balance of Payment (as % of service exports) in 2007 in North America to that in Argentina?
Ensure brevity in your answer.  0.81. What is the ratio of the Balance of Payment (as % of service exports) of 2008 in North America to that in Argentina?
Your answer should be very brief. 0.91. What is the ratio of the Balance of Payment (as % of service exports) in 2005 in OECD members to that in South Asia?
Provide a succinct answer. 1.42. What is the ratio of the Balance of Payment (as % of service exports) in 2006 in OECD members to that in South Asia?
Your answer should be very brief. 1.42. What is the ratio of the Balance of Payment (as % of service exports) in 2007 in OECD members to that in South Asia?
Provide a short and direct response. 1.55. What is the ratio of the Balance of Payment (as % of service exports) of 2008 in OECD members to that in South Asia?
Offer a terse response. 1.59. What is the ratio of the Balance of Payment (as % of service exports) in 2005 in OECD members to that in World?
Your response must be concise. 0.96. What is the ratio of the Balance of Payment (as % of service exports) in 2006 in OECD members to that in World?
Offer a very short reply. 0.95. What is the ratio of the Balance of Payment (as % of service exports) in 2007 in OECD members to that in World?
Ensure brevity in your answer.  0.95. What is the ratio of the Balance of Payment (as % of service exports) in 2008 in OECD members to that in World?
Offer a terse response. 0.96. What is the ratio of the Balance of Payment (as % of service exports) in 2005 in OECD members to that in Albania?
Give a very brief answer. 2.02. What is the ratio of the Balance of Payment (as % of service exports) of 2006 in OECD members to that in Albania?
Your answer should be very brief. 1.98. What is the ratio of the Balance of Payment (as % of service exports) in 2007 in OECD members to that in Albania?
Your answer should be very brief. 2.64. What is the ratio of the Balance of Payment (as % of service exports) in 2008 in OECD members to that in Albania?
Your response must be concise. 2.6. What is the ratio of the Balance of Payment (as % of service exports) of 2005 in OECD members to that in Argentina?
Ensure brevity in your answer.  1. What is the ratio of the Balance of Payment (as % of service exports) of 2006 in OECD members to that in Argentina?
Ensure brevity in your answer.  1.05. What is the ratio of the Balance of Payment (as % of service exports) of 2007 in OECD members to that in Argentina?
Offer a very short reply. 1.15. What is the ratio of the Balance of Payment (as % of service exports) in 2008 in OECD members to that in Argentina?
Give a very brief answer. 1.31. What is the ratio of the Balance of Payment (as % of service exports) in 2005 in South Asia to that in World?
Provide a short and direct response. 0.67. What is the ratio of the Balance of Payment (as % of service exports) of 2006 in South Asia to that in World?
Offer a terse response. 0.67. What is the ratio of the Balance of Payment (as % of service exports) of 2007 in South Asia to that in World?
Offer a very short reply. 0.62. What is the ratio of the Balance of Payment (as % of service exports) of 2008 in South Asia to that in World?
Offer a very short reply. 0.6. What is the ratio of the Balance of Payment (as % of service exports) in 2005 in South Asia to that in Albania?
Your response must be concise. 1.43. What is the ratio of the Balance of Payment (as % of service exports) of 2006 in South Asia to that in Albania?
Offer a very short reply. 1.39. What is the ratio of the Balance of Payment (as % of service exports) of 2007 in South Asia to that in Albania?
Offer a terse response. 1.7. What is the ratio of the Balance of Payment (as % of service exports) of 2008 in South Asia to that in Albania?
Ensure brevity in your answer.  1.63. What is the ratio of the Balance of Payment (as % of service exports) in 2005 in South Asia to that in Argentina?
Ensure brevity in your answer.  0.7. What is the ratio of the Balance of Payment (as % of service exports) of 2006 in South Asia to that in Argentina?
Your response must be concise. 0.73. What is the ratio of the Balance of Payment (as % of service exports) of 2007 in South Asia to that in Argentina?
Your answer should be compact. 0.74. What is the ratio of the Balance of Payment (as % of service exports) in 2008 in South Asia to that in Argentina?
Offer a terse response. 0.82. What is the ratio of the Balance of Payment (as % of service exports) in 2005 in World to that in Albania?
Your answer should be very brief. 2.12. What is the ratio of the Balance of Payment (as % of service exports) of 2006 in World to that in Albania?
Your answer should be very brief. 2.08. What is the ratio of the Balance of Payment (as % of service exports) in 2007 in World to that in Albania?
Ensure brevity in your answer.  2.76. What is the ratio of the Balance of Payment (as % of service exports) in 2008 in World to that in Albania?
Offer a terse response. 2.72. What is the ratio of the Balance of Payment (as % of service exports) in 2005 in World to that in Argentina?
Make the answer very short. 1.04. What is the ratio of the Balance of Payment (as % of service exports) in 2006 in World to that in Argentina?
Keep it short and to the point. 1.1. What is the ratio of the Balance of Payment (as % of service exports) in 2007 in World to that in Argentina?
Give a very brief answer. 1.21. What is the ratio of the Balance of Payment (as % of service exports) of 2008 in World to that in Argentina?
Your answer should be compact. 1.37. What is the ratio of the Balance of Payment (as % of service exports) of 2005 in Albania to that in Argentina?
Offer a terse response. 0.49. What is the ratio of the Balance of Payment (as % of service exports) in 2006 in Albania to that in Argentina?
Your answer should be very brief. 0.53. What is the ratio of the Balance of Payment (as % of service exports) of 2007 in Albania to that in Argentina?
Your response must be concise. 0.44. What is the ratio of the Balance of Payment (as % of service exports) of 2008 in Albania to that in Argentina?
Provide a succinct answer. 0.5. What is the difference between the highest and the second highest Balance of Payment (as % of service exports) in 2005?
Your answer should be very brief. 0.89. What is the difference between the highest and the second highest Balance of Payment (as % of service exports) in 2006?
Provide a short and direct response. 0.95. What is the difference between the highest and the second highest Balance of Payment (as % of service exports) in 2007?
Offer a terse response. 0.94. What is the difference between the highest and the second highest Balance of Payment (as % of service exports) of 2008?
Offer a very short reply. 0.96. What is the difference between the highest and the lowest Balance of Payment (as % of service exports) in 2005?
Keep it short and to the point. 11.12. What is the difference between the highest and the lowest Balance of Payment (as % of service exports) of 2006?
Provide a succinct answer. 10.72. What is the difference between the highest and the lowest Balance of Payment (as % of service exports) of 2007?
Give a very brief answer. 13.26. What is the difference between the highest and the lowest Balance of Payment (as % of service exports) of 2008?
Your answer should be compact. 13.68. 